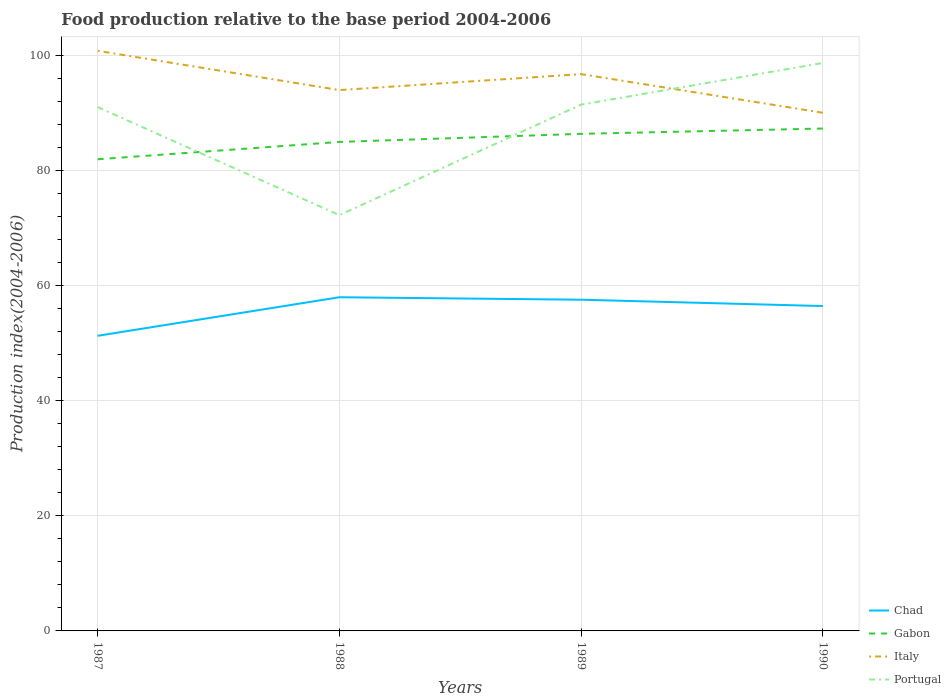How many different coloured lines are there?
Your answer should be very brief. 4. Does the line corresponding to Portugal intersect with the line corresponding to Italy?
Your answer should be very brief. Yes. Is the number of lines equal to the number of legend labels?
Make the answer very short. Yes. Across all years, what is the maximum food production index in Portugal?
Your response must be concise. 72.23. What is the total food production index in Portugal in the graph?
Keep it short and to the point. -19.2. What is the difference between the highest and the second highest food production index in Chad?
Ensure brevity in your answer.  6.7. What is the difference between the highest and the lowest food production index in Italy?
Offer a terse response. 2. Is the food production index in Chad strictly greater than the food production index in Portugal over the years?
Offer a terse response. Yes. How many lines are there?
Make the answer very short. 4. Does the graph contain any zero values?
Offer a terse response. No. Where does the legend appear in the graph?
Ensure brevity in your answer.  Bottom right. How many legend labels are there?
Ensure brevity in your answer.  4. How are the legend labels stacked?
Offer a very short reply. Vertical. What is the title of the graph?
Offer a very short reply. Food production relative to the base period 2004-2006. Does "Kyrgyz Republic" appear as one of the legend labels in the graph?
Your answer should be very brief. No. What is the label or title of the Y-axis?
Offer a very short reply. Production index(2004-2006). What is the Production index(2004-2006) of Chad in 1987?
Offer a terse response. 51.27. What is the Production index(2004-2006) of Gabon in 1987?
Provide a short and direct response. 81.94. What is the Production index(2004-2006) of Italy in 1987?
Offer a terse response. 100.78. What is the Production index(2004-2006) of Portugal in 1987?
Your answer should be compact. 91. What is the Production index(2004-2006) of Chad in 1988?
Offer a terse response. 57.97. What is the Production index(2004-2006) in Gabon in 1988?
Provide a short and direct response. 84.95. What is the Production index(2004-2006) in Italy in 1988?
Keep it short and to the point. 93.96. What is the Production index(2004-2006) in Portugal in 1988?
Your response must be concise. 72.23. What is the Production index(2004-2006) in Chad in 1989?
Your answer should be compact. 57.54. What is the Production index(2004-2006) of Gabon in 1989?
Provide a short and direct response. 86.36. What is the Production index(2004-2006) in Italy in 1989?
Give a very brief answer. 96.73. What is the Production index(2004-2006) in Portugal in 1989?
Your answer should be compact. 91.43. What is the Production index(2004-2006) in Chad in 1990?
Offer a very short reply. 56.44. What is the Production index(2004-2006) in Gabon in 1990?
Your response must be concise. 87.28. What is the Production index(2004-2006) in Italy in 1990?
Your answer should be very brief. 90.02. What is the Production index(2004-2006) in Portugal in 1990?
Your answer should be compact. 98.67. Across all years, what is the maximum Production index(2004-2006) in Chad?
Offer a very short reply. 57.97. Across all years, what is the maximum Production index(2004-2006) in Gabon?
Provide a succinct answer. 87.28. Across all years, what is the maximum Production index(2004-2006) in Italy?
Offer a terse response. 100.78. Across all years, what is the maximum Production index(2004-2006) in Portugal?
Give a very brief answer. 98.67. Across all years, what is the minimum Production index(2004-2006) of Chad?
Provide a succinct answer. 51.27. Across all years, what is the minimum Production index(2004-2006) of Gabon?
Provide a short and direct response. 81.94. Across all years, what is the minimum Production index(2004-2006) in Italy?
Offer a very short reply. 90.02. Across all years, what is the minimum Production index(2004-2006) of Portugal?
Provide a succinct answer. 72.23. What is the total Production index(2004-2006) of Chad in the graph?
Your answer should be very brief. 223.22. What is the total Production index(2004-2006) of Gabon in the graph?
Keep it short and to the point. 340.53. What is the total Production index(2004-2006) of Italy in the graph?
Provide a short and direct response. 381.49. What is the total Production index(2004-2006) of Portugal in the graph?
Make the answer very short. 353.33. What is the difference between the Production index(2004-2006) of Chad in 1987 and that in 1988?
Provide a short and direct response. -6.7. What is the difference between the Production index(2004-2006) in Gabon in 1987 and that in 1988?
Your answer should be compact. -3.01. What is the difference between the Production index(2004-2006) of Italy in 1987 and that in 1988?
Offer a very short reply. 6.82. What is the difference between the Production index(2004-2006) in Portugal in 1987 and that in 1988?
Ensure brevity in your answer.  18.77. What is the difference between the Production index(2004-2006) in Chad in 1987 and that in 1989?
Keep it short and to the point. -6.27. What is the difference between the Production index(2004-2006) in Gabon in 1987 and that in 1989?
Make the answer very short. -4.42. What is the difference between the Production index(2004-2006) of Italy in 1987 and that in 1989?
Offer a very short reply. 4.05. What is the difference between the Production index(2004-2006) of Portugal in 1987 and that in 1989?
Offer a terse response. -0.43. What is the difference between the Production index(2004-2006) of Chad in 1987 and that in 1990?
Your answer should be compact. -5.17. What is the difference between the Production index(2004-2006) of Gabon in 1987 and that in 1990?
Your response must be concise. -5.34. What is the difference between the Production index(2004-2006) of Italy in 1987 and that in 1990?
Provide a short and direct response. 10.76. What is the difference between the Production index(2004-2006) of Portugal in 1987 and that in 1990?
Provide a short and direct response. -7.67. What is the difference between the Production index(2004-2006) in Chad in 1988 and that in 1989?
Offer a very short reply. 0.43. What is the difference between the Production index(2004-2006) of Gabon in 1988 and that in 1989?
Give a very brief answer. -1.41. What is the difference between the Production index(2004-2006) of Italy in 1988 and that in 1989?
Give a very brief answer. -2.77. What is the difference between the Production index(2004-2006) in Portugal in 1988 and that in 1989?
Your answer should be very brief. -19.2. What is the difference between the Production index(2004-2006) in Chad in 1988 and that in 1990?
Keep it short and to the point. 1.53. What is the difference between the Production index(2004-2006) of Gabon in 1988 and that in 1990?
Your answer should be compact. -2.33. What is the difference between the Production index(2004-2006) in Italy in 1988 and that in 1990?
Keep it short and to the point. 3.94. What is the difference between the Production index(2004-2006) of Portugal in 1988 and that in 1990?
Keep it short and to the point. -26.44. What is the difference between the Production index(2004-2006) in Gabon in 1989 and that in 1990?
Provide a succinct answer. -0.92. What is the difference between the Production index(2004-2006) in Italy in 1989 and that in 1990?
Provide a succinct answer. 6.71. What is the difference between the Production index(2004-2006) in Portugal in 1989 and that in 1990?
Provide a succinct answer. -7.24. What is the difference between the Production index(2004-2006) of Chad in 1987 and the Production index(2004-2006) of Gabon in 1988?
Keep it short and to the point. -33.68. What is the difference between the Production index(2004-2006) of Chad in 1987 and the Production index(2004-2006) of Italy in 1988?
Make the answer very short. -42.69. What is the difference between the Production index(2004-2006) in Chad in 1987 and the Production index(2004-2006) in Portugal in 1988?
Ensure brevity in your answer.  -20.96. What is the difference between the Production index(2004-2006) of Gabon in 1987 and the Production index(2004-2006) of Italy in 1988?
Provide a short and direct response. -12.02. What is the difference between the Production index(2004-2006) of Gabon in 1987 and the Production index(2004-2006) of Portugal in 1988?
Make the answer very short. 9.71. What is the difference between the Production index(2004-2006) of Italy in 1987 and the Production index(2004-2006) of Portugal in 1988?
Offer a terse response. 28.55. What is the difference between the Production index(2004-2006) of Chad in 1987 and the Production index(2004-2006) of Gabon in 1989?
Give a very brief answer. -35.09. What is the difference between the Production index(2004-2006) of Chad in 1987 and the Production index(2004-2006) of Italy in 1989?
Your answer should be very brief. -45.46. What is the difference between the Production index(2004-2006) in Chad in 1987 and the Production index(2004-2006) in Portugal in 1989?
Provide a succinct answer. -40.16. What is the difference between the Production index(2004-2006) in Gabon in 1987 and the Production index(2004-2006) in Italy in 1989?
Make the answer very short. -14.79. What is the difference between the Production index(2004-2006) of Gabon in 1987 and the Production index(2004-2006) of Portugal in 1989?
Keep it short and to the point. -9.49. What is the difference between the Production index(2004-2006) in Italy in 1987 and the Production index(2004-2006) in Portugal in 1989?
Your answer should be very brief. 9.35. What is the difference between the Production index(2004-2006) of Chad in 1987 and the Production index(2004-2006) of Gabon in 1990?
Your answer should be compact. -36.01. What is the difference between the Production index(2004-2006) of Chad in 1987 and the Production index(2004-2006) of Italy in 1990?
Your answer should be very brief. -38.75. What is the difference between the Production index(2004-2006) of Chad in 1987 and the Production index(2004-2006) of Portugal in 1990?
Your response must be concise. -47.4. What is the difference between the Production index(2004-2006) in Gabon in 1987 and the Production index(2004-2006) in Italy in 1990?
Your response must be concise. -8.08. What is the difference between the Production index(2004-2006) of Gabon in 1987 and the Production index(2004-2006) of Portugal in 1990?
Provide a succinct answer. -16.73. What is the difference between the Production index(2004-2006) in Italy in 1987 and the Production index(2004-2006) in Portugal in 1990?
Provide a short and direct response. 2.11. What is the difference between the Production index(2004-2006) in Chad in 1988 and the Production index(2004-2006) in Gabon in 1989?
Keep it short and to the point. -28.39. What is the difference between the Production index(2004-2006) of Chad in 1988 and the Production index(2004-2006) of Italy in 1989?
Ensure brevity in your answer.  -38.76. What is the difference between the Production index(2004-2006) in Chad in 1988 and the Production index(2004-2006) in Portugal in 1989?
Provide a succinct answer. -33.46. What is the difference between the Production index(2004-2006) of Gabon in 1988 and the Production index(2004-2006) of Italy in 1989?
Provide a short and direct response. -11.78. What is the difference between the Production index(2004-2006) in Gabon in 1988 and the Production index(2004-2006) in Portugal in 1989?
Offer a very short reply. -6.48. What is the difference between the Production index(2004-2006) in Italy in 1988 and the Production index(2004-2006) in Portugal in 1989?
Keep it short and to the point. 2.53. What is the difference between the Production index(2004-2006) of Chad in 1988 and the Production index(2004-2006) of Gabon in 1990?
Keep it short and to the point. -29.31. What is the difference between the Production index(2004-2006) of Chad in 1988 and the Production index(2004-2006) of Italy in 1990?
Your response must be concise. -32.05. What is the difference between the Production index(2004-2006) in Chad in 1988 and the Production index(2004-2006) in Portugal in 1990?
Provide a short and direct response. -40.7. What is the difference between the Production index(2004-2006) in Gabon in 1988 and the Production index(2004-2006) in Italy in 1990?
Your answer should be very brief. -5.07. What is the difference between the Production index(2004-2006) of Gabon in 1988 and the Production index(2004-2006) of Portugal in 1990?
Your answer should be very brief. -13.72. What is the difference between the Production index(2004-2006) in Italy in 1988 and the Production index(2004-2006) in Portugal in 1990?
Your response must be concise. -4.71. What is the difference between the Production index(2004-2006) of Chad in 1989 and the Production index(2004-2006) of Gabon in 1990?
Offer a very short reply. -29.74. What is the difference between the Production index(2004-2006) in Chad in 1989 and the Production index(2004-2006) in Italy in 1990?
Your answer should be compact. -32.48. What is the difference between the Production index(2004-2006) of Chad in 1989 and the Production index(2004-2006) of Portugal in 1990?
Provide a short and direct response. -41.13. What is the difference between the Production index(2004-2006) of Gabon in 1989 and the Production index(2004-2006) of Italy in 1990?
Keep it short and to the point. -3.66. What is the difference between the Production index(2004-2006) of Gabon in 1989 and the Production index(2004-2006) of Portugal in 1990?
Offer a terse response. -12.31. What is the difference between the Production index(2004-2006) of Italy in 1989 and the Production index(2004-2006) of Portugal in 1990?
Offer a very short reply. -1.94. What is the average Production index(2004-2006) in Chad per year?
Offer a terse response. 55.8. What is the average Production index(2004-2006) of Gabon per year?
Make the answer very short. 85.13. What is the average Production index(2004-2006) of Italy per year?
Offer a terse response. 95.37. What is the average Production index(2004-2006) in Portugal per year?
Make the answer very short. 88.33. In the year 1987, what is the difference between the Production index(2004-2006) in Chad and Production index(2004-2006) in Gabon?
Ensure brevity in your answer.  -30.67. In the year 1987, what is the difference between the Production index(2004-2006) in Chad and Production index(2004-2006) in Italy?
Provide a succinct answer. -49.51. In the year 1987, what is the difference between the Production index(2004-2006) of Chad and Production index(2004-2006) of Portugal?
Provide a succinct answer. -39.73. In the year 1987, what is the difference between the Production index(2004-2006) in Gabon and Production index(2004-2006) in Italy?
Offer a very short reply. -18.84. In the year 1987, what is the difference between the Production index(2004-2006) of Gabon and Production index(2004-2006) of Portugal?
Your response must be concise. -9.06. In the year 1987, what is the difference between the Production index(2004-2006) of Italy and Production index(2004-2006) of Portugal?
Make the answer very short. 9.78. In the year 1988, what is the difference between the Production index(2004-2006) of Chad and Production index(2004-2006) of Gabon?
Offer a very short reply. -26.98. In the year 1988, what is the difference between the Production index(2004-2006) of Chad and Production index(2004-2006) of Italy?
Offer a very short reply. -35.99. In the year 1988, what is the difference between the Production index(2004-2006) of Chad and Production index(2004-2006) of Portugal?
Your response must be concise. -14.26. In the year 1988, what is the difference between the Production index(2004-2006) in Gabon and Production index(2004-2006) in Italy?
Your answer should be compact. -9.01. In the year 1988, what is the difference between the Production index(2004-2006) in Gabon and Production index(2004-2006) in Portugal?
Offer a terse response. 12.72. In the year 1988, what is the difference between the Production index(2004-2006) in Italy and Production index(2004-2006) in Portugal?
Give a very brief answer. 21.73. In the year 1989, what is the difference between the Production index(2004-2006) in Chad and Production index(2004-2006) in Gabon?
Ensure brevity in your answer.  -28.82. In the year 1989, what is the difference between the Production index(2004-2006) in Chad and Production index(2004-2006) in Italy?
Keep it short and to the point. -39.19. In the year 1989, what is the difference between the Production index(2004-2006) of Chad and Production index(2004-2006) of Portugal?
Provide a short and direct response. -33.89. In the year 1989, what is the difference between the Production index(2004-2006) in Gabon and Production index(2004-2006) in Italy?
Your answer should be compact. -10.37. In the year 1989, what is the difference between the Production index(2004-2006) of Gabon and Production index(2004-2006) of Portugal?
Ensure brevity in your answer.  -5.07. In the year 1990, what is the difference between the Production index(2004-2006) of Chad and Production index(2004-2006) of Gabon?
Offer a very short reply. -30.84. In the year 1990, what is the difference between the Production index(2004-2006) of Chad and Production index(2004-2006) of Italy?
Give a very brief answer. -33.58. In the year 1990, what is the difference between the Production index(2004-2006) of Chad and Production index(2004-2006) of Portugal?
Your response must be concise. -42.23. In the year 1990, what is the difference between the Production index(2004-2006) in Gabon and Production index(2004-2006) in Italy?
Your response must be concise. -2.74. In the year 1990, what is the difference between the Production index(2004-2006) in Gabon and Production index(2004-2006) in Portugal?
Your answer should be compact. -11.39. In the year 1990, what is the difference between the Production index(2004-2006) of Italy and Production index(2004-2006) of Portugal?
Make the answer very short. -8.65. What is the ratio of the Production index(2004-2006) in Chad in 1987 to that in 1988?
Give a very brief answer. 0.88. What is the ratio of the Production index(2004-2006) in Gabon in 1987 to that in 1988?
Provide a succinct answer. 0.96. What is the ratio of the Production index(2004-2006) of Italy in 1987 to that in 1988?
Offer a terse response. 1.07. What is the ratio of the Production index(2004-2006) of Portugal in 1987 to that in 1988?
Keep it short and to the point. 1.26. What is the ratio of the Production index(2004-2006) in Chad in 1987 to that in 1989?
Your answer should be very brief. 0.89. What is the ratio of the Production index(2004-2006) of Gabon in 1987 to that in 1989?
Provide a succinct answer. 0.95. What is the ratio of the Production index(2004-2006) in Italy in 1987 to that in 1989?
Make the answer very short. 1.04. What is the ratio of the Production index(2004-2006) in Chad in 1987 to that in 1990?
Your answer should be very brief. 0.91. What is the ratio of the Production index(2004-2006) in Gabon in 1987 to that in 1990?
Your answer should be very brief. 0.94. What is the ratio of the Production index(2004-2006) of Italy in 1987 to that in 1990?
Offer a terse response. 1.12. What is the ratio of the Production index(2004-2006) in Portugal in 1987 to that in 1990?
Provide a succinct answer. 0.92. What is the ratio of the Production index(2004-2006) in Chad in 1988 to that in 1989?
Your response must be concise. 1.01. What is the ratio of the Production index(2004-2006) of Gabon in 1988 to that in 1989?
Provide a succinct answer. 0.98. What is the ratio of the Production index(2004-2006) in Italy in 1988 to that in 1989?
Provide a short and direct response. 0.97. What is the ratio of the Production index(2004-2006) in Portugal in 1988 to that in 1989?
Keep it short and to the point. 0.79. What is the ratio of the Production index(2004-2006) of Chad in 1988 to that in 1990?
Make the answer very short. 1.03. What is the ratio of the Production index(2004-2006) of Gabon in 1988 to that in 1990?
Your response must be concise. 0.97. What is the ratio of the Production index(2004-2006) in Italy in 1988 to that in 1990?
Ensure brevity in your answer.  1.04. What is the ratio of the Production index(2004-2006) in Portugal in 1988 to that in 1990?
Make the answer very short. 0.73. What is the ratio of the Production index(2004-2006) of Chad in 1989 to that in 1990?
Your answer should be compact. 1.02. What is the ratio of the Production index(2004-2006) of Gabon in 1989 to that in 1990?
Your answer should be compact. 0.99. What is the ratio of the Production index(2004-2006) of Italy in 1989 to that in 1990?
Offer a very short reply. 1.07. What is the ratio of the Production index(2004-2006) of Portugal in 1989 to that in 1990?
Ensure brevity in your answer.  0.93. What is the difference between the highest and the second highest Production index(2004-2006) in Chad?
Give a very brief answer. 0.43. What is the difference between the highest and the second highest Production index(2004-2006) of Italy?
Offer a very short reply. 4.05. What is the difference between the highest and the second highest Production index(2004-2006) in Portugal?
Your response must be concise. 7.24. What is the difference between the highest and the lowest Production index(2004-2006) of Chad?
Make the answer very short. 6.7. What is the difference between the highest and the lowest Production index(2004-2006) in Gabon?
Your answer should be very brief. 5.34. What is the difference between the highest and the lowest Production index(2004-2006) of Italy?
Your response must be concise. 10.76. What is the difference between the highest and the lowest Production index(2004-2006) of Portugal?
Provide a short and direct response. 26.44. 